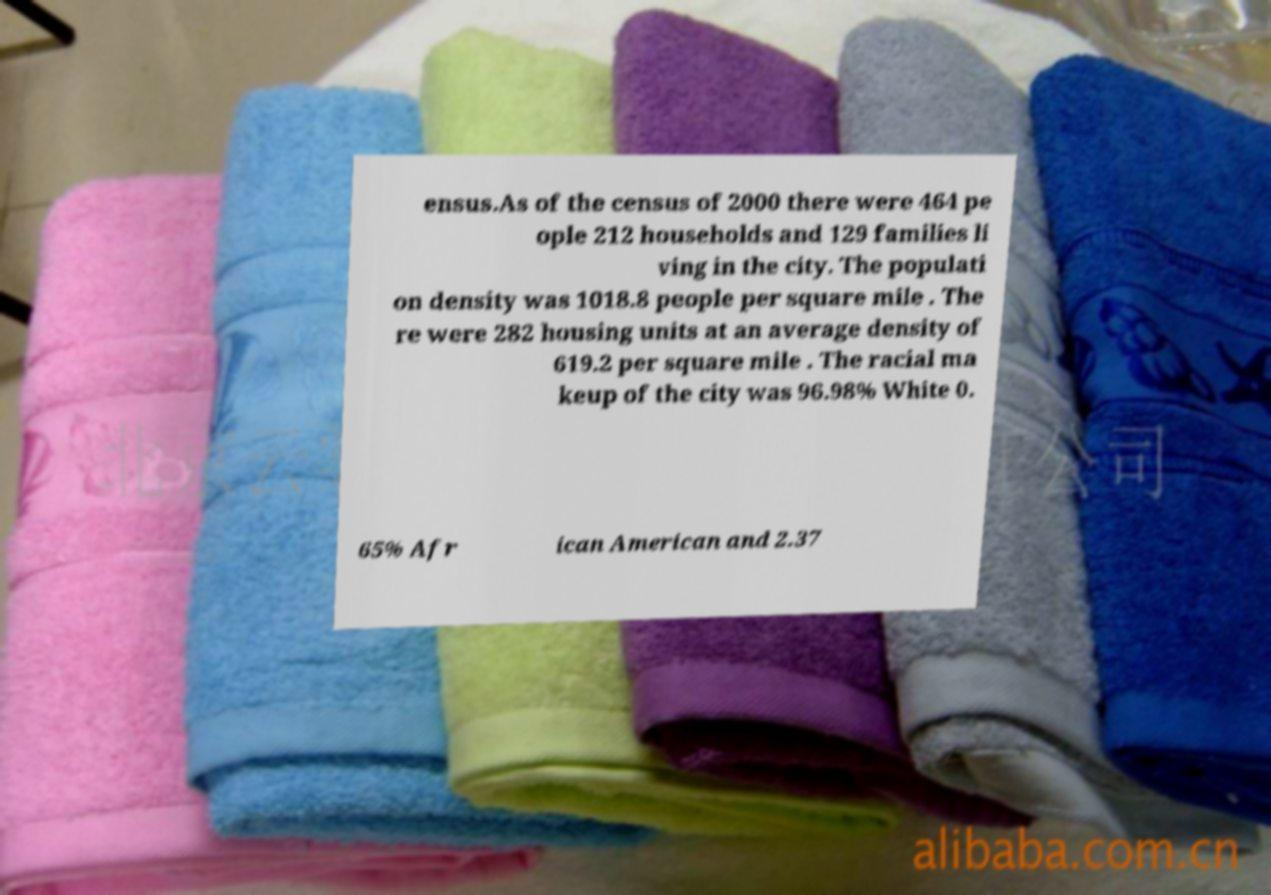Please identify and transcribe the text found in this image. ensus.As of the census of 2000 there were 464 pe ople 212 households and 129 families li ving in the city. The populati on density was 1018.8 people per square mile . The re were 282 housing units at an average density of 619.2 per square mile . The racial ma keup of the city was 96.98% White 0. 65% Afr ican American and 2.37 